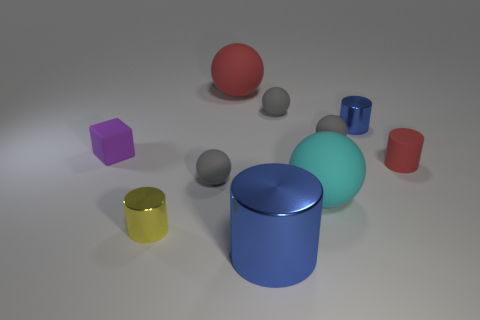What material is the big sphere that is the same color as the small matte cylinder?
Provide a succinct answer. Rubber. The cyan rubber object that is the same shape as the large red thing is what size?
Offer a very short reply. Large. How many objects are either tiny gray matte objects that are to the right of the cyan sphere or tiny gray balls that are behind the cyan rubber thing?
Give a very brief answer. 3. Do the yellow shiny thing and the red cylinder have the same size?
Provide a short and direct response. Yes. Are there more yellow matte blocks than large cyan rubber things?
Make the answer very short. No. What number of other things are there of the same color as the matte cube?
Provide a short and direct response. 0. What number of objects are tiny purple matte objects or yellow cylinders?
Ensure brevity in your answer.  2. There is a red thing to the right of the big blue object; is its shape the same as the large blue shiny thing?
Offer a terse response. Yes. There is a small rubber object that is to the right of the metal thing behind the cyan object; what color is it?
Keep it short and to the point. Red. Are there fewer small gray matte balls than small cubes?
Provide a short and direct response. No. 